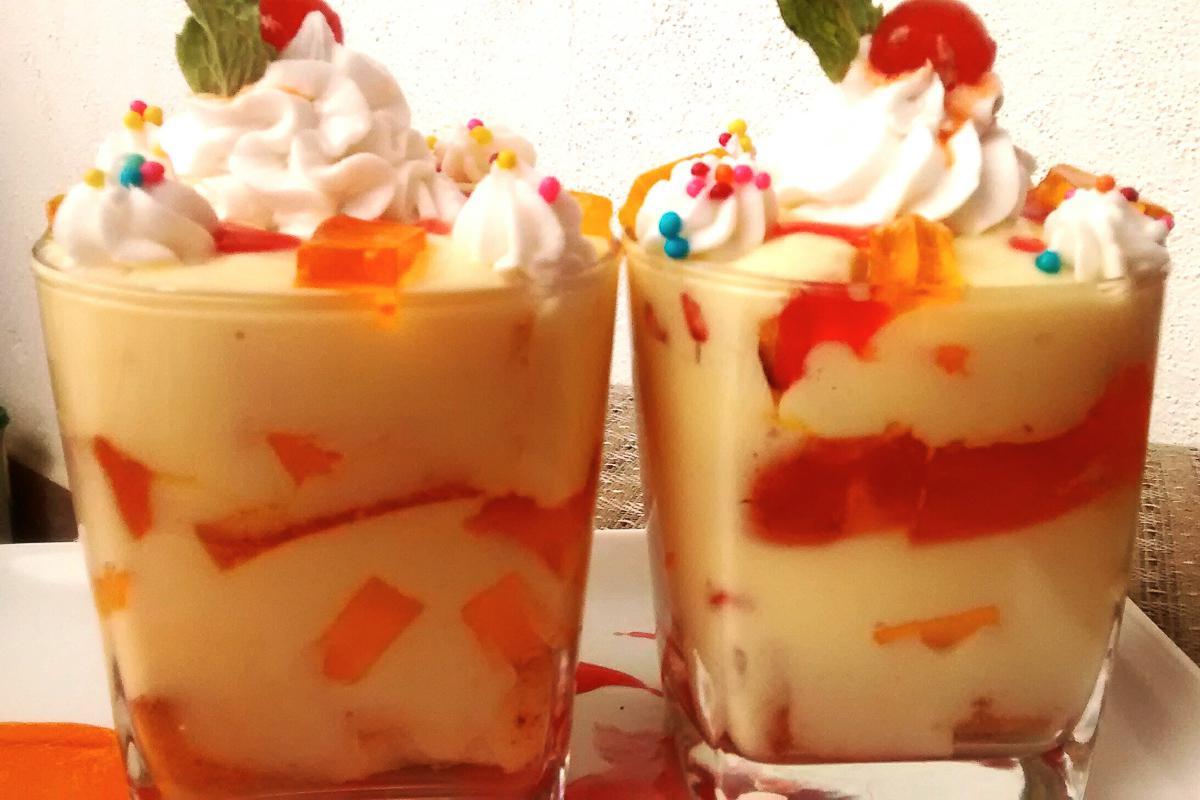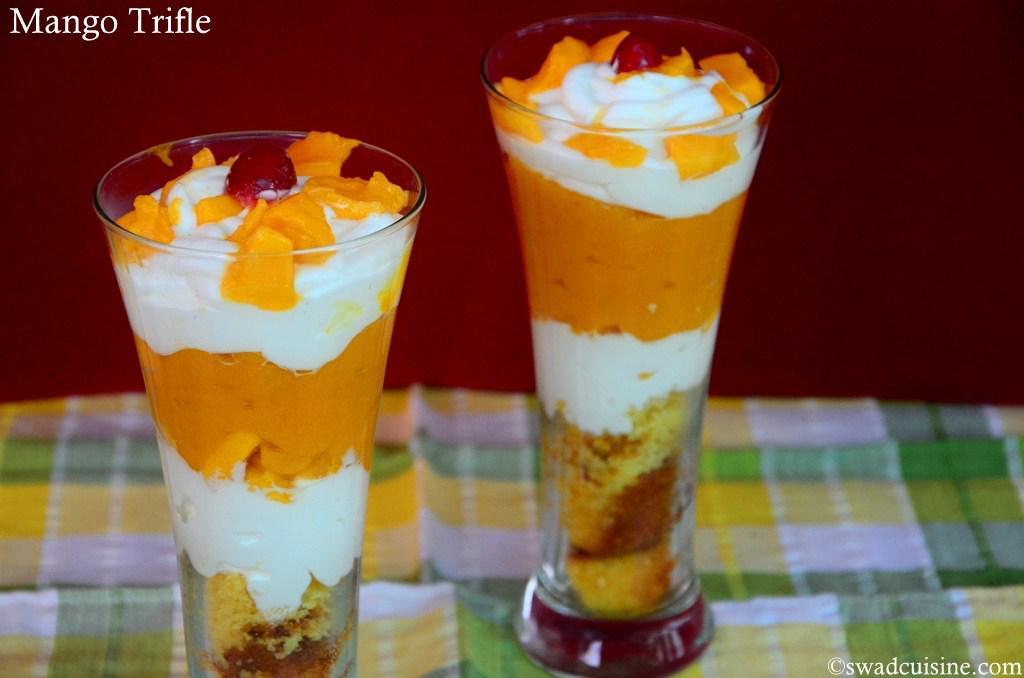The first image is the image on the left, the second image is the image on the right. Analyze the images presented: Is the assertion "There are at least 4 parfaits resting on a table." valid? Answer yes or no. Yes. 